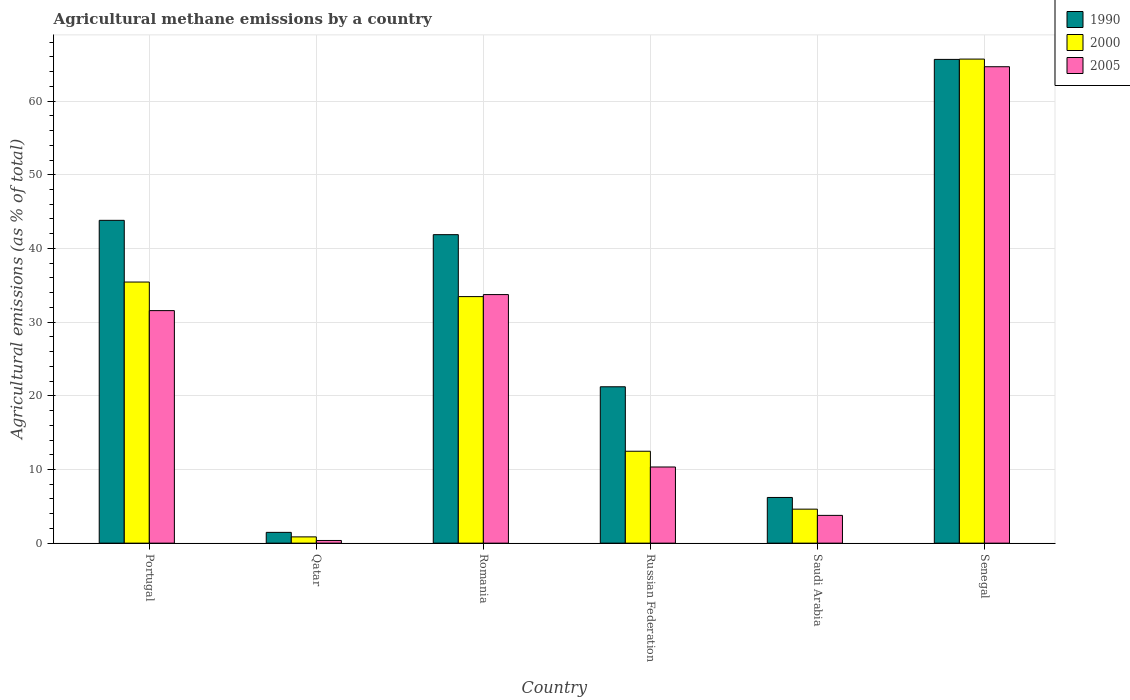How many different coloured bars are there?
Make the answer very short. 3. Are the number of bars per tick equal to the number of legend labels?
Your answer should be compact. Yes. Are the number of bars on each tick of the X-axis equal?
Your response must be concise. Yes. How many bars are there on the 4th tick from the right?
Your answer should be compact. 3. What is the label of the 4th group of bars from the left?
Ensure brevity in your answer.  Russian Federation. What is the amount of agricultural methane emitted in 1990 in Portugal?
Ensure brevity in your answer.  43.82. Across all countries, what is the maximum amount of agricultural methane emitted in 2005?
Offer a terse response. 64.67. Across all countries, what is the minimum amount of agricultural methane emitted in 1990?
Offer a very short reply. 1.46. In which country was the amount of agricultural methane emitted in 2000 maximum?
Your response must be concise. Senegal. In which country was the amount of agricultural methane emitted in 1990 minimum?
Give a very brief answer. Qatar. What is the total amount of agricultural methane emitted in 1990 in the graph?
Offer a very short reply. 180.24. What is the difference between the amount of agricultural methane emitted in 2000 in Portugal and that in Qatar?
Ensure brevity in your answer.  34.59. What is the difference between the amount of agricultural methane emitted in 2005 in Russian Federation and the amount of agricultural methane emitted in 1990 in Saudi Arabia?
Provide a short and direct response. 4.13. What is the average amount of agricultural methane emitted in 1990 per country?
Provide a succinct answer. 30.04. What is the difference between the amount of agricultural methane emitted of/in 2000 and amount of agricultural methane emitted of/in 2005 in Russian Federation?
Make the answer very short. 2.14. What is the ratio of the amount of agricultural methane emitted in 2000 in Portugal to that in Saudi Arabia?
Provide a short and direct response. 7.68. Is the amount of agricultural methane emitted in 1990 in Romania less than that in Senegal?
Your answer should be very brief. Yes. What is the difference between the highest and the second highest amount of agricultural methane emitted in 2000?
Make the answer very short. 30.26. What is the difference between the highest and the lowest amount of agricultural methane emitted in 2000?
Your answer should be compact. 64.86. How many bars are there?
Give a very brief answer. 18. Are all the bars in the graph horizontal?
Give a very brief answer. No. How many countries are there in the graph?
Your answer should be compact. 6. Are the values on the major ticks of Y-axis written in scientific E-notation?
Your answer should be compact. No. Does the graph contain any zero values?
Your answer should be very brief. No. Does the graph contain grids?
Your answer should be compact. Yes. How are the legend labels stacked?
Ensure brevity in your answer.  Vertical. What is the title of the graph?
Your answer should be compact. Agricultural methane emissions by a country. Does "1960" appear as one of the legend labels in the graph?
Your answer should be compact. No. What is the label or title of the X-axis?
Offer a very short reply. Country. What is the label or title of the Y-axis?
Your response must be concise. Agricultural emissions (as % of total). What is the Agricultural emissions (as % of total) of 1990 in Portugal?
Keep it short and to the point. 43.82. What is the Agricultural emissions (as % of total) of 2000 in Portugal?
Provide a short and direct response. 35.44. What is the Agricultural emissions (as % of total) of 2005 in Portugal?
Offer a terse response. 31.56. What is the Agricultural emissions (as % of total) in 1990 in Qatar?
Your answer should be very brief. 1.46. What is the Agricultural emissions (as % of total) of 2000 in Qatar?
Give a very brief answer. 0.85. What is the Agricultural emissions (as % of total) of 2005 in Qatar?
Make the answer very short. 0.36. What is the Agricultural emissions (as % of total) in 1990 in Romania?
Offer a very short reply. 41.87. What is the Agricultural emissions (as % of total) of 2000 in Romania?
Keep it short and to the point. 33.46. What is the Agricultural emissions (as % of total) in 2005 in Romania?
Offer a very short reply. 33.74. What is the Agricultural emissions (as % of total) in 1990 in Russian Federation?
Make the answer very short. 21.22. What is the Agricultural emissions (as % of total) in 2000 in Russian Federation?
Provide a succinct answer. 12.47. What is the Agricultural emissions (as % of total) of 2005 in Russian Federation?
Offer a very short reply. 10.34. What is the Agricultural emissions (as % of total) in 1990 in Saudi Arabia?
Provide a succinct answer. 6.2. What is the Agricultural emissions (as % of total) in 2000 in Saudi Arabia?
Your answer should be compact. 4.61. What is the Agricultural emissions (as % of total) of 2005 in Saudi Arabia?
Your answer should be compact. 3.77. What is the Agricultural emissions (as % of total) in 1990 in Senegal?
Offer a terse response. 65.66. What is the Agricultural emissions (as % of total) of 2000 in Senegal?
Your answer should be compact. 65.71. What is the Agricultural emissions (as % of total) in 2005 in Senegal?
Make the answer very short. 64.67. Across all countries, what is the maximum Agricultural emissions (as % of total) of 1990?
Provide a succinct answer. 65.66. Across all countries, what is the maximum Agricultural emissions (as % of total) of 2000?
Provide a succinct answer. 65.71. Across all countries, what is the maximum Agricultural emissions (as % of total) in 2005?
Offer a very short reply. 64.67. Across all countries, what is the minimum Agricultural emissions (as % of total) in 1990?
Give a very brief answer. 1.46. Across all countries, what is the minimum Agricultural emissions (as % of total) in 2000?
Provide a short and direct response. 0.85. Across all countries, what is the minimum Agricultural emissions (as % of total) of 2005?
Provide a succinct answer. 0.36. What is the total Agricultural emissions (as % of total) of 1990 in the graph?
Give a very brief answer. 180.24. What is the total Agricultural emissions (as % of total) in 2000 in the graph?
Keep it short and to the point. 152.55. What is the total Agricultural emissions (as % of total) in 2005 in the graph?
Your response must be concise. 144.44. What is the difference between the Agricultural emissions (as % of total) in 1990 in Portugal and that in Qatar?
Offer a terse response. 42.35. What is the difference between the Agricultural emissions (as % of total) of 2000 in Portugal and that in Qatar?
Your response must be concise. 34.59. What is the difference between the Agricultural emissions (as % of total) in 2005 in Portugal and that in Qatar?
Offer a very short reply. 31.2. What is the difference between the Agricultural emissions (as % of total) of 1990 in Portugal and that in Romania?
Your answer should be very brief. 1.94. What is the difference between the Agricultural emissions (as % of total) of 2000 in Portugal and that in Romania?
Your answer should be very brief. 1.98. What is the difference between the Agricultural emissions (as % of total) in 2005 in Portugal and that in Romania?
Keep it short and to the point. -2.18. What is the difference between the Agricultural emissions (as % of total) in 1990 in Portugal and that in Russian Federation?
Your response must be concise. 22.59. What is the difference between the Agricultural emissions (as % of total) of 2000 in Portugal and that in Russian Federation?
Give a very brief answer. 22.97. What is the difference between the Agricultural emissions (as % of total) in 2005 in Portugal and that in Russian Federation?
Your response must be concise. 21.23. What is the difference between the Agricultural emissions (as % of total) in 1990 in Portugal and that in Saudi Arabia?
Your response must be concise. 37.62. What is the difference between the Agricultural emissions (as % of total) in 2000 in Portugal and that in Saudi Arabia?
Offer a terse response. 30.83. What is the difference between the Agricultural emissions (as % of total) in 2005 in Portugal and that in Saudi Arabia?
Provide a succinct answer. 27.79. What is the difference between the Agricultural emissions (as % of total) of 1990 in Portugal and that in Senegal?
Make the answer very short. -21.85. What is the difference between the Agricultural emissions (as % of total) in 2000 in Portugal and that in Senegal?
Provide a succinct answer. -30.26. What is the difference between the Agricultural emissions (as % of total) in 2005 in Portugal and that in Senegal?
Keep it short and to the point. -33.11. What is the difference between the Agricultural emissions (as % of total) in 1990 in Qatar and that in Romania?
Your answer should be compact. -40.41. What is the difference between the Agricultural emissions (as % of total) of 2000 in Qatar and that in Romania?
Keep it short and to the point. -32.62. What is the difference between the Agricultural emissions (as % of total) in 2005 in Qatar and that in Romania?
Your answer should be very brief. -33.38. What is the difference between the Agricultural emissions (as % of total) in 1990 in Qatar and that in Russian Federation?
Your response must be concise. -19.76. What is the difference between the Agricultural emissions (as % of total) in 2000 in Qatar and that in Russian Federation?
Make the answer very short. -11.63. What is the difference between the Agricultural emissions (as % of total) of 2005 in Qatar and that in Russian Federation?
Your answer should be compact. -9.97. What is the difference between the Agricultural emissions (as % of total) in 1990 in Qatar and that in Saudi Arabia?
Your response must be concise. -4.74. What is the difference between the Agricultural emissions (as % of total) in 2000 in Qatar and that in Saudi Arabia?
Make the answer very short. -3.76. What is the difference between the Agricultural emissions (as % of total) of 2005 in Qatar and that in Saudi Arabia?
Your answer should be compact. -3.41. What is the difference between the Agricultural emissions (as % of total) in 1990 in Qatar and that in Senegal?
Make the answer very short. -64.2. What is the difference between the Agricultural emissions (as % of total) of 2000 in Qatar and that in Senegal?
Your answer should be compact. -64.86. What is the difference between the Agricultural emissions (as % of total) in 2005 in Qatar and that in Senegal?
Give a very brief answer. -64.31. What is the difference between the Agricultural emissions (as % of total) of 1990 in Romania and that in Russian Federation?
Make the answer very short. 20.65. What is the difference between the Agricultural emissions (as % of total) in 2000 in Romania and that in Russian Federation?
Your response must be concise. 20.99. What is the difference between the Agricultural emissions (as % of total) in 2005 in Romania and that in Russian Federation?
Offer a terse response. 23.4. What is the difference between the Agricultural emissions (as % of total) of 1990 in Romania and that in Saudi Arabia?
Provide a succinct answer. 35.67. What is the difference between the Agricultural emissions (as % of total) in 2000 in Romania and that in Saudi Arabia?
Ensure brevity in your answer.  28.85. What is the difference between the Agricultural emissions (as % of total) of 2005 in Romania and that in Saudi Arabia?
Your response must be concise. 29.97. What is the difference between the Agricultural emissions (as % of total) of 1990 in Romania and that in Senegal?
Your answer should be compact. -23.79. What is the difference between the Agricultural emissions (as % of total) of 2000 in Romania and that in Senegal?
Provide a succinct answer. -32.24. What is the difference between the Agricultural emissions (as % of total) of 2005 in Romania and that in Senegal?
Provide a succinct answer. -30.93. What is the difference between the Agricultural emissions (as % of total) of 1990 in Russian Federation and that in Saudi Arabia?
Make the answer very short. 15.02. What is the difference between the Agricultural emissions (as % of total) in 2000 in Russian Federation and that in Saudi Arabia?
Offer a very short reply. 7.86. What is the difference between the Agricultural emissions (as % of total) of 2005 in Russian Federation and that in Saudi Arabia?
Give a very brief answer. 6.57. What is the difference between the Agricultural emissions (as % of total) in 1990 in Russian Federation and that in Senegal?
Ensure brevity in your answer.  -44.44. What is the difference between the Agricultural emissions (as % of total) in 2000 in Russian Federation and that in Senegal?
Keep it short and to the point. -53.23. What is the difference between the Agricultural emissions (as % of total) of 2005 in Russian Federation and that in Senegal?
Give a very brief answer. -54.33. What is the difference between the Agricultural emissions (as % of total) of 1990 in Saudi Arabia and that in Senegal?
Your answer should be very brief. -59.46. What is the difference between the Agricultural emissions (as % of total) of 2000 in Saudi Arabia and that in Senegal?
Make the answer very short. -61.09. What is the difference between the Agricultural emissions (as % of total) in 2005 in Saudi Arabia and that in Senegal?
Make the answer very short. -60.9. What is the difference between the Agricultural emissions (as % of total) in 1990 in Portugal and the Agricultural emissions (as % of total) in 2000 in Qatar?
Ensure brevity in your answer.  42.97. What is the difference between the Agricultural emissions (as % of total) in 1990 in Portugal and the Agricultural emissions (as % of total) in 2005 in Qatar?
Offer a very short reply. 43.45. What is the difference between the Agricultural emissions (as % of total) of 2000 in Portugal and the Agricultural emissions (as % of total) of 2005 in Qatar?
Give a very brief answer. 35.08. What is the difference between the Agricultural emissions (as % of total) of 1990 in Portugal and the Agricultural emissions (as % of total) of 2000 in Romania?
Provide a succinct answer. 10.35. What is the difference between the Agricultural emissions (as % of total) of 1990 in Portugal and the Agricultural emissions (as % of total) of 2005 in Romania?
Offer a very short reply. 10.08. What is the difference between the Agricultural emissions (as % of total) in 2000 in Portugal and the Agricultural emissions (as % of total) in 2005 in Romania?
Ensure brevity in your answer.  1.7. What is the difference between the Agricultural emissions (as % of total) in 1990 in Portugal and the Agricultural emissions (as % of total) in 2000 in Russian Federation?
Your answer should be very brief. 31.34. What is the difference between the Agricultural emissions (as % of total) in 1990 in Portugal and the Agricultural emissions (as % of total) in 2005 in Russian Federation?
Provide a succinct answer. 33.48. What is the difference between the Agricultural emissions (as % of total) of 2000 in Portugal and the Agricultural emissions (as % of total) of 2005 in Russian Federation?
Keep it short and to the point. 25.1. What is the difference between the Agricultural emissions (as % of total) of 1990 in Portugal and the Agricultural emissions (as % of total) of 2000 in Saudi Arabia?
Keep it short and to the point. 39.2. What is the difference between the Agricultural emissions (as % of total) of 1990 in Portugal and the Agricultural emissions (as % of total) of 2005 in Saudi Arabia?
Provide a short and direct response. 40.05. What is the difference between the Agricultural emissions (as % of total) in 2000 in Portugal and the Agricultural emissions (as % of total) in 2005 in Saudi Arabia?
Keep it short and to the point. 31.67. What is the difference between the Agricultural emissions (as % of total) in 1990 in Portugal and the Agricultural emissions (as % of total) in 2000 in Senegal?
Give a very brief answer. -21.89. What is the difference between the Agricultural emissions (as % of total) in 1990 in Portugal and the Agricultural emissions (as % of total) in 2005 in Senegal?
Your answer should be very brief. -20.85. What is the difference between the Agricultural emissions (as % of total) of 2000 in Portugal and the Agricultural emissions (as % of total) of 2005 in Senegal?
Your answer should be compact. -29.23. What is the difference between the Agricultural emissions (as % of total) of 1990 in Qatar and the Agricultural emissions (as % of total) of 2000 in Romania?
Make the answer very short. -32. What is the difference between the Agricultural emissions (as % of total) in 1990 in Qatar and the Agricultural emissions (as % of total) in 2005 in Romania?
Give a very brief answer. -32.27. What is the difference between the Agricultural emissions (as % of total) in 2000 in Qatar and the Agricultural emissions (as % of total) in 2005 in Romania?
Your answer should be compact. -32.89. What is the difference between the Agricultural emissions (as % of total) of 1990 in Qatar and the Agricultural emissions (as % of total) of 2000 in Russian Federation?
Make the answer very short. -11.01. What is the difference between the Agricultural emissions (as % of total) in 1990 in Qatar and the Agricultural emissions (as % of total) in 2005 in Russian Federation?
Make the answer very short. -8.87. What is the difference between the Agricultural emissions (as % of total) in 2000 in Qatar and the Agricultural emissions (as % of total) in 2005 in Russian Federation?
Make the answer very short. -9.49. What is the difference between the Agricultural emissions (as % of total) in 1990 in Qatar and the Agricultural emissions (as % of total) in 2000 in Saudi Arabia?
Offer a very short reply. -3.15. What is the difference between the Agricultural emissions (as % of total) of 1990 in Qatar and the Agricultural emissions (as % of total) of 2005 in Saudi Arabia?
Your response must be concise. -2.31. What is the difference between the Agricultural emissions (as % of total) of 2000 in Qatar and the Agricultural emissions (as % of total) of 2005 in Saudi Arabia?
Your answer should be compact. -2.92. What is the difference between the Agricultural emissions (as % of total) in 1990 in Qatar and the Agricultural emissions (as % of total) in 2000 in Senegal?
Your answer should be compact. -64.24. What is the difference between the Agricultural emissions (as % of total) of 1990 in Qatar and the Agricultural emissions (as % of total) of 2005 in Senegal?
Your response must be concise. -63.2. What is the difference between the Agricultural emissions (as % of total) in 2000 in Qatar and the Agricultural emissions (as % of total) in 2005 in Senegal?
Give a very brief answer. -63.82. What is the difference between the Agricultural emissions (as % of total) in 1990 in Romania and the Agricultural emissions (as % of total) in 2000 in Russian Federation?
Offer a terse response. 29.4. What is the difference between the Agricultural emissions (as % of total) of 1990 in Romania and the Agricultural emissions (as % of total) of 2005 in Russian Federation?
Provide a succinct answer. 31.54. What is the difference between the Agricultural emissions (as % of total) in 2000 in Romania and the Agricultural emissions (as % of total) in 2005 in Russian Federation?
Your answer should be very brief. 23.13. What is the difference between the Agricultural emissions (as % of total) in 1990 in Romania and the Agricultural emissions (as % of total) in 2000 in Saudi Arabia?
Provide a succinct answer. 37.26. What is the difference between the Agricultural emissions (as % of total) in 1990 in Romania and the Agricultural emissions (as % of total) in 2005 in Saudi Arabia?
Offer a very short reply. 38.1. What is the difference between the Agricultural emissions (as % of total) of 2000 in Romania and the Agricultural emissions (as % of total) of 2005 in Saudi Arabia?
Ensure brevity in your answer.  29.69. What is the difference between the Agricultural emissions (as % of total) in 1990 in Romania and the Agricultural emissions (as % of total) in 2000 in Senegal?
Offer a terse response. -23.83. What is the difference between the Agricultural emissions (as % of total) in 1990 in Romania and the Agricultural emissions (as % of total) in 2005 in Senegal?
Make the answer very short. -22.8. What is the difference between the Agricultural emissions (as % of total) of 2000 in Romania and the Agricultural emissions (as % of total) of 2005 in Senegal?
Offer a very short reply. -31.2. What is the difference between the Agricultural emissions (as % of total) in 1990 in Russian Federation and the Agricultural emissions (as % of total) in 2000 in Saudi Arabia?
Your answer should be very brief. 16.61. What is the difference between the Agricultural emissions (as % of total) of 1990 in Russian Federation and the Agricultural emissions (as % of total) of 2005 in Saudi Arabia?
Offer a very short reply. 17.45. What is the difference between the Agricultural emissions (as % of total) in 2000 in Russian Federation and the Agricultural emissions (as % of total) in 2005 in Saudi Arabia?
Your answer should be compact. 8.71. What is the difference between the Agricultural emissions (as % of total) of 1990 in Russian Federation and the Agricultural emissions (as % of total) of 2000 in Senegal?
Give a very brief answer. -44.48. What is the difference between the Agricultural emissions (as % of total) in 1990 in Russian Federation and the Agricultural emissions (as % of total) in 2005 in Senegal?
Your answer should be very brief. -43.44. What is the difference between the Agricultural emissions (as % of total) of 2000 in Russian Federation and the Agricultural emissions (as % of total) of 2005 in Senegal?
Provide a succinct answer. -52.19. What is the difference between the Agricultural emissions (as % of total) in 1990 in Saudi Arabia and the Agricultural emissions (as % of total) in 2000 in Senegal?
Your answer should be very brief. -59.5. What is the difference between the Agricultural emissions (as % of total) of 1990 in Saudi Arabia and the Agricultural emissions (as % of total) of 2005 in Senegal?
Your answer should be compact. -58.47. What is the difference between the Agricultural emissions (as % of total) in 2000 in Saudi Arabia and the Agricultural emissions (as % of total) in 2005 in Senegal?
Give a very brief answer. -60.05. What is the average Agricultural emissions (as % of total) in 1990 per country?
Your response must be concise. 30.04. What is the average Agricultural emissions (as % of total) of 2000 per country?
Provide a short and direct response. 25.42. What is the average Agricultural emissions (as % of total) of 2005 per country?
Your answer should be compact. 24.07. What is the difference between the Agricultural emissions (as % of total) in 1990 and Agricultural emissions (as % of total) in 2000 in Portugal?
Offer a terse response. 8.38. What is the difference between the Agricultural emissions (as % of total) of 1990 and Agricultural emissions (as % of total) of 2005 in Portugal?
Your answer should be very brief. 12.26. What is the difference between the Agricultural emissions (as % of total) of 2000 and Agricultural emissions (as % of total) of 2005 in Portugal?
Keep it short and to the point. 3.88. What is the difference between the Agricultural emissions (as % of total) in 1990 and Agricultural emissions (as % of total) in 2000 in Qatar?
Your answer should be very brief. 0.61. What is the difference between the Agricultural emissions (as % of total) in 1990 and Agricultural emissions (as % of total) in 2005 in Qatar?
Provide a short and direct response. 1.1. What is the difference between the Agricultural emissions (as % of total) in 2000 and Agricultural emissions (as % of total) in 2005 in Qatar?
Your response must be concise. 0.49. What is the difference between the Agricultural emissions (as % of total) in 1990 and Agricultural emissions (as % of total) in 2000 in Romania?
Ensure brevity in your answer.  8.41. What is the difference between the Agricultural emissions (as % of total) of 1990 and Agricultural emissions (as % of total) of 2005 in Romania?
Give a very brief answer. 8.13. What is the difference between the Agricultural emissions (as % of total) in 2000 and Agricultural emissions (as % of total) in 2005 in Romania?
Your answer should be very brief. -0.27. What is the difference between the Agricultural emissions (as % of total) of 1990 and Agricultural emissions (as % of total) of 2000 in Russian Federation?
Provide a short and direct response. 8.75. What is the difference between the Agricultural emissions (as % of total) in 1990 and Agricultural emissions (as % of total) in 2005 in Russian Federation?
Give a very brief answer. 10.89. What is the difference between the Agricultural emissions (as % of total) of 2000 and Agricultural emissions (as % of total) of 2005 in Russian Federation?
Provide a succinct answer. 2.14. What is the difference between the Agricultural emissions (as % of total) in 1990 and Agricultural emissions (as % of total) in 2000 in Saudi Arabia?
Your answer should be compact. 1.59. What is the difference between the Agricultural emissions (as % of total) in 1990 and Agricultural emissions (as % of total) in 2005 in Saudi Arabia?
Your answer should be very brief. 2.43. What is the difference between the Agricultural emissions (as % of total) of 2000 and Agricultural emissions (as % of total) of 2005 in Saudi Arabia?
Offer a terse response. 0.84. What is the difference between the Agricultural emissions (as % of total) in 1990 and Agricultural emissions (as % of total) in 2000 in Senegal?
Offer a very short reply. -0.04. What is the difference between the Agricultural emissions (as % of total) of 1990 and Agricultural emissions (as % of total) of 2005 in Senegal?
Give a very brief answer. 0.99. What is the difference between the Agricultural emissions (as % of total) in 2000 and Agricultural emissions (as % of total) in 2005 in Senegal?
Your answer should be compact. 1.04. What is the ratio of the Agricultural emissions (as % of total) in 1990 in Portugal to that in Qatar?
Your response must be concise. 29.94. What is the ratio of the Agricultural emissions (as % of total) in 2000 in Portugal to that in Qatar?
Provide a succinct answer. 41.75. What is the ratio of the Agricultural emissions (as % of total) in 2005 in Portugal to that in Qatar?
Your response must be concise. 87.01. What is the ratio of the Agricultural emissions (as % of total) in 1990 in Portugal to that in Romania?
Your answer should be compact. 1.05. What is the ratio of the Agricultural emissions (as % of total) of 2000 in Portugal to that in Romania?
Your answer should be very brief. 1.06. What is the ratio of the Agricultural emissions (as % of total) in 2005 in Portugal to that in Romania?
Ensure brevity in your answer.  0.94. What is the ratio of the Agricultural emissions (as % of total) in 1990 in Portugal to that in Russian Federation?
Your answer should be compact. 2.06. What is the ratio of the Agricultural emissions (as % of total) in 2000 in Portugal to that in Russian Federation?
Give a very brief answer. 2.84. What is the ratio of the Agricultural emissions (as % of total) of 2005 in Portugal to that in Russian Federation?
Provide a succinct answer. 3.05. What is the ratio of the Agricultural emissions (as % of total) in 1990 in Portugal to that in Saudi Arabia?
Give a very brief answer. 7.07. What is the ratio of the Agricultural emissions (as % of total) of 2000 in Portugal to that in Saudi Arabia?
Keep it short and to the point. 7.68. What is the ratio of the Agricultural emissions (as % of total) in 2005 in Portugal to that in Saudi Arabia?
Your answer should be compact. 8.37. What is the ratio of the Agricultural emissions (as % of total) in 1990 in Portugal to that in Senegal?
Give a very brief answer. 0.67. What is the ratio of the Agricultural emissions (as % of total) in 2000 in Portugal to that in Senegal?
Offer a terse response. 0.54. What is the ratio of the Agricultural emissions (as % of total) in 2005 in Portugal to that in Senegal?
Your answer should be compact. 0.49. What is the ratio of the Agricultural emissions (as % of total) of 1990 in Qatar to that in Romania?
Ensure brevity in your answer.  0.04. What is the ratio of the Agricultural emissions (as % of total) of 2000 in Qatar to that in Romania?
Your answer should be compact. 0.03. What is the ratio of the Agricultural emissions (as % of total) in 2005 in Qatar to that in Romania?
Give a very brief answer. 0.01. What is the ratio of the Agricultural emissions (as % of total) of 1990 in Qatar to that in Russian Federation?
Offer a terse response. 0.07. What is the ratio of the Agricultural emissions (as % of total) of 2000 in Qatar to that in Russian Federation?
Provide a short and direct response. 0.07. What is the ratio of the Agricultural emissions (as % of total) of 2005 in Qatar to that in Russian Federation?
Offer a very short reply. 0.04. What is the ratio of the Agricultural emissions (as % of total) of 1990 in Qatar to that in Saudi Arabia?
Your response must be concise. 0.24. What is the ratio of the Agricultural emissions (as % of total) of 2000 in Qatar to that in Saudi Arabia?
Ensure brevity in your answer.  0.18. What is the ratio of the Agricultural emissions (as % of total) of 2005 in Qatar to that in Saudi Arabia?
Provide a succinct answer. 0.1. What is the ratio of the Agricultural emissions (as % of total) in 1990 in Qatar to that in Senegal?
Your response must be concise. 0.02. What is the ratio of the Agricultural emissions (as % of total) in 2000 in Qatar to that in Senegal?
Provide a succinct answer. 0.01. What is the ratio of the Agricultural emissions (as % of total) in 2005 in Qatar to that in Senegal?
Your response must be concise. 0.01. What is the ratio of the Agricultural emissions (as % of total) in 1990 in Romania to that in Russian Federation?
Offer a very short reply. 1.97. What is the ratio of the Agricultural emissions (as % of total) of 2000 in Romania to that in Russian Federation?
Keep it short and to the point. 2.68. What is the ratio of the Agricultural emissions (as % of total) in 2005 in Romania to that in Russian Federation?
Keep it short and to the point. 3.26. What is the ratio of the Agricultural emissions (as % of total) in 1990 in Romania to that in Saudi Arabia?
Provide a short and direct response. 6.75. What is the ratio of the Agricultural emissions (as % of total) of 2000 in Romania to that in Saudi Arabia?
Your answer should be very brief. 7.25. What is the ratio of the Agricultural emissions (as % of total) in 2005 in Romania to that in Saudi Arabia?
Offer a very short reply. 8.95. What is the ratio of the Agricultural emissions (as % of total) of 1990 in Romania to that in Senegal?
Your answer should be compact. 0.64. What is the ratio of the Agricultural emissions (as % of total) in 2000 in Romania to that in Senegal?
Your response must be concise. 0.51. What is the ratio of the Agricultural emissions (as % of total) of 2005 in Romania to that in Senegal?
Ensure brevity in your answer.  0.52. What is the ratio of the Agricultural emissions (as % of total) of 1990 in Russian Federation to that in Saudi Arabia?
Make the answer very short. 3.42. What is the ratio of the Agricultural emissions (as % of total) of 2000 in Russian Federation to that in Saudi Arabia?
Your answer should be compact. 2.7. What is the ratio of the Agricultural emissions (as % of total) in 2005 in Russian Federation to that in Saudi Arabia?
Offer a very short reply. 2.74. What is the ratio of the Agricultural emissions (as % of total) in 1990 in Russian Federation to that in Senegal?
Make the answer very short. 0.32. What is the ratio of the Agricultural emissions (as % of total) of 2000 in Russian Federation to that in Senegal?
Offer a terse response. 0.19. What is the ratio of the Agricultural emissions (as % of total) in 2005 in Russian Federation to that in Senegal?
Your answer should be compact. 0.16. What is the ratio of the Agricultural emissions (as % of total) in 1990 in Saudi Arabia to that in Senegal?
Your response must be concise. 0.09. What is the ratio of the Agricultural emissions (as % of total) in 2000 in Saudi Arabia to that in Senegal?
Offer a very short reply. 0.07. What is the ratio of the Agricultural emissions (as % of total) of 2005 in Saudi Arabia to that in Senegal?
Offer a terse response. 0.06. What is the difference between the highest and the second highest Agricultural emissions (as % of total) in 1990?
Provide a short and direct response. 21.85. What is the difference between the highest and the second highest Agricultural emissions (as % of total) of 2000?
Your answer should be compact. 30.26. What is the difference between the highest and the second highest Agricultural emissions (as % of total) in 2005?
Offer a very short reply. 30.93. What is the difference between the highest and the lowest Agricultural emissions (as % of total) in 1990?
Provide a short and direct response. 64.2. What is the difference between the highest and the lowest Agricultural emissions (as % of total) of 2000?
Provide a succinct answer. 64.86. What is the difference between the highest and the lowest Agricultural emissions (as % of total) in 2005?
Your response must be concise. 64.31. 